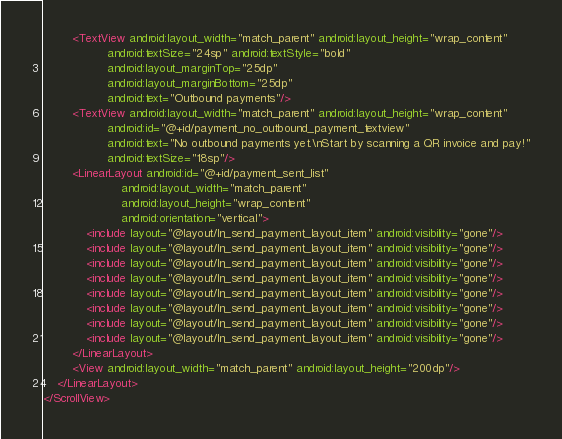Convert code to text. <code><loc_0><loc_0><loc_500><loc_500><_XML_>        <TextView android:layout_width="match_parent" android:layout_height="wrap_content"
                  android:textSize="24sp" android:textStyle="bold"
                  android:layout_marginTop="25dp"
                  android:layout_marginBottom="25dp"
                  android:text="Outbound payments"/>
        <TextView android:layout_width="match_parent" android:layout_height="wrap_content"
                  android:id="@+id/payment_no_outbound_payment_textview"
                  android:text="No outbound payments yet.\nStart by scanning a QR invoice and pay!"
                  android:textSize="18sp"/>
        <LinearLayout android:id="@+id/payment_sent_list"
                      android:layout_width="match_parent"
                      android:layout_height="wrap_content"
                      android:orientation="vertical">
            <include layout="@layout/ln_send_payment_layout_item" android:visibility="gone"/>
            <include layout="@layout/ln_send_payment_layout_item" android:visibility="gone"/>
            <include layout="@layout/ln_send_payment_layout_item" android:visibility="gone"/>
            <include layout="@layout/ln_send_payment_layout_item" android:visibility="gone"/>
            <include layout="@layout/ln_send_payment_layout_item" android:visibility="gone"/>
            <include layout="@layout/ln_send_payment_layout_item" android:visibility="gone"/>
            <include layout="@layout/ln_send_payment_layout_item" android:visibility="gone"/>
            <include layout="@layout/ln_send_payment_layout_item" android:visibility="gone"/>
        </LinearLayout>
        <View android:layout_width="match_parent" android:layout_height="200dp"/>
    </LinearLayout>
</ScrollView></code> 